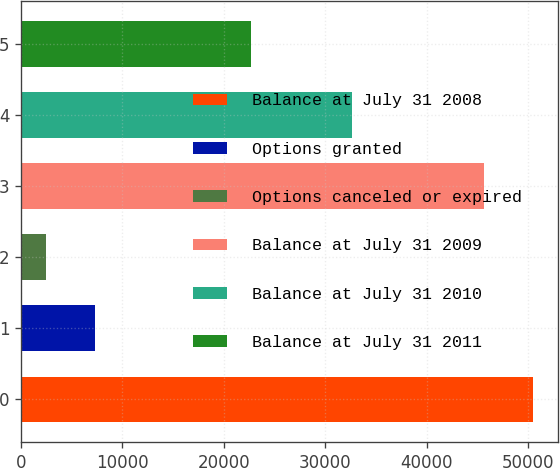Convert chart. <chart><loc_0><loc_0><loc_500><loc_500><bar_chart><fcel>Balance at July 31 2008<fcel>Options granted<fcel>Options canceled or expired<fcel>Balance at July 31 2009<fcel>Balance at July 31 2010<fcel>Balance at July 31 2011<nl><fcel>50445.8<fcel>7259.8<fcel>2488<fcel>45674<fcel>32593<fcel>22679<nl></chart> 